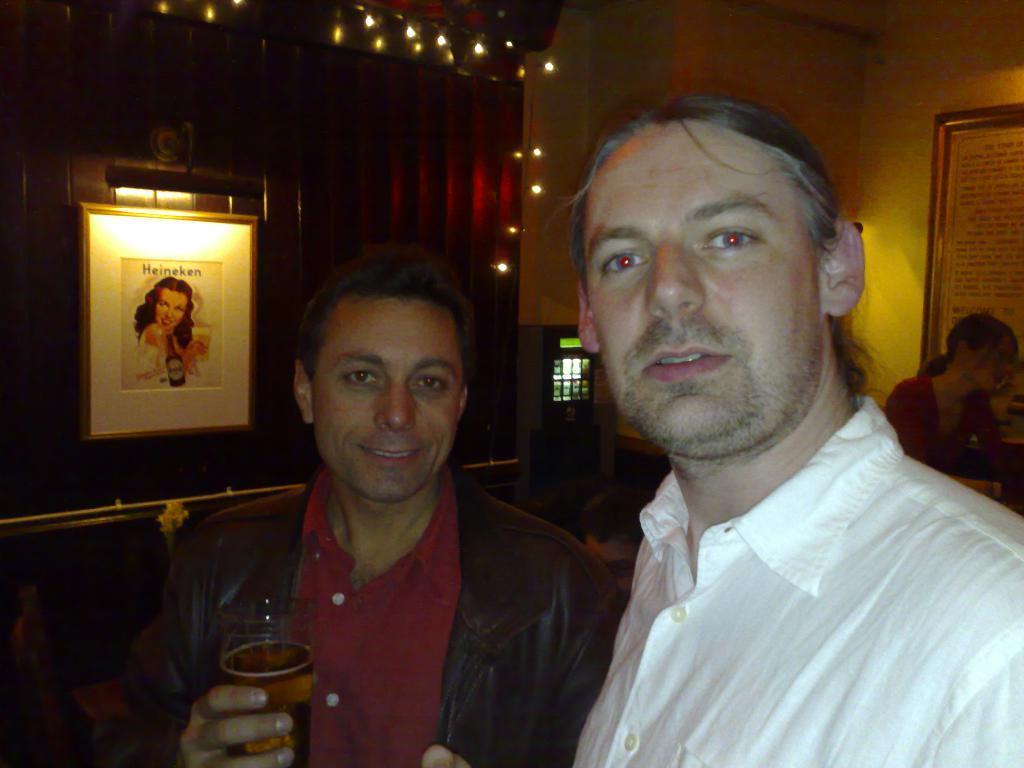Can you describe this image briefly? As we can see in the image there is a yellow color wall, photo frame, a poster, two people standing in the front. The man who is standing on the left side is wearing black color jacket and holding a glass and the man on the right side is wearing white color shirt. 